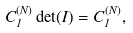<formula> <loc_0><loc_0><loc_500><loc_500>C ^ { ( N ) } _ { 1 } \det ( I ) = C ^ { ( N ) } _ { 1 } ,</formula> 